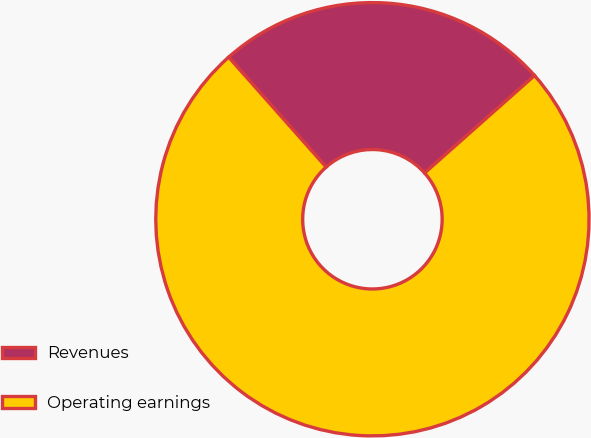<chart> <loc_0><loc_0><loc_500><loc_500><pie_chart><fcel>Revenues<fcel>Operating earnings<nl><fcel>25.0%<fcel>75.0%<nl></chart> 